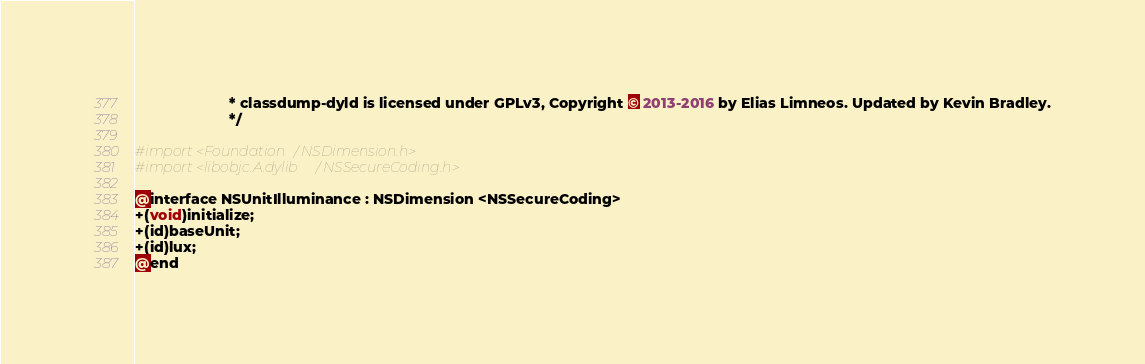Convert code to text. <code><loc_0><loc_0><loc_500><loc_500><_C_>                       * classdump-dyld is licensed under GPLv3, Copyright © 2013-2016 by Elias Limneos. Updated by Kevin Bradley.
                       */

#import <Foundation/NSDimension.h>
#import <libobjc.A.dylib/NSSecureCoding.h>

@interface NSUnitIlluminance : NSDimension <NSSecureCoding>
+(void)initialize;
+(id)baseUnit;
+(id)lux;
@end

</code> 